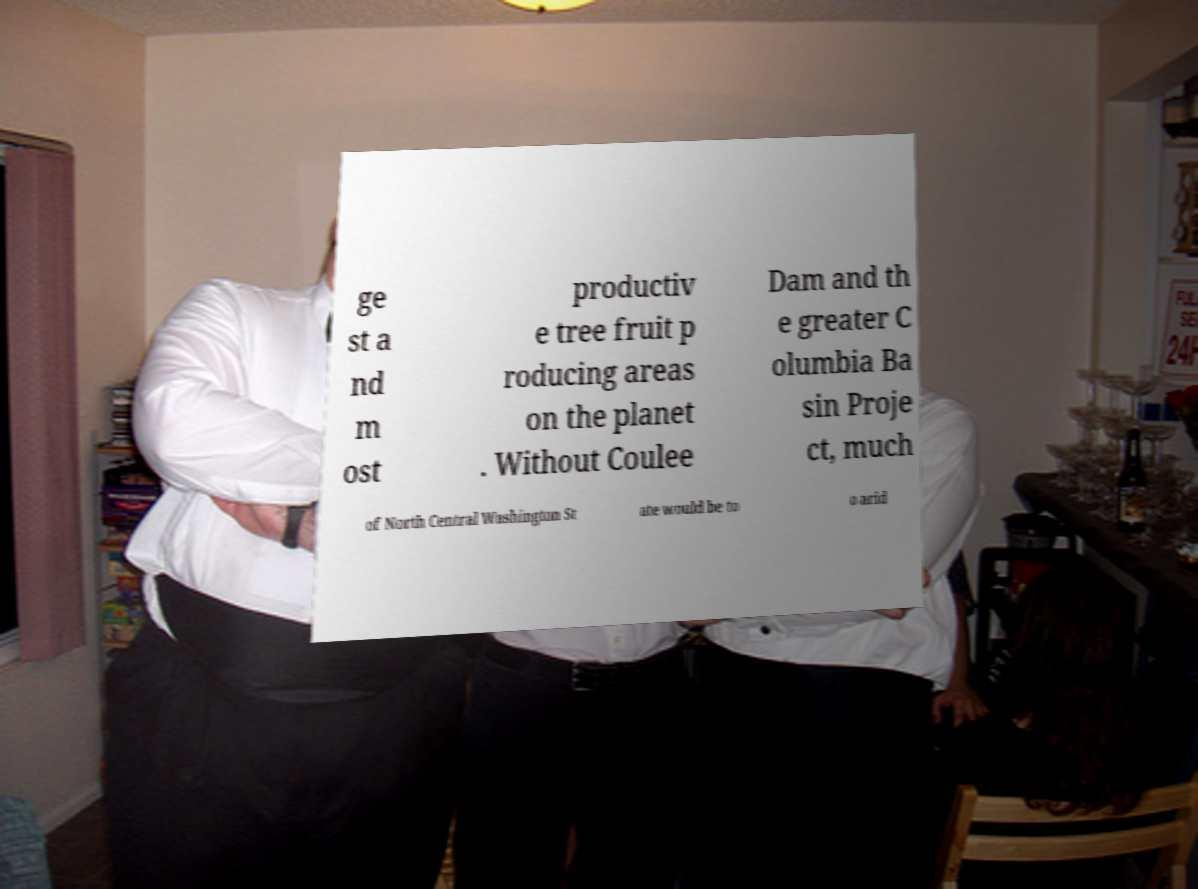Please read and relay the text visible in this image. What does it say? ge st a nd m ost productiv e tree fruit p roducing areas on the planet . Without Coulee Dam and th e greater C olumbia Ba sin Proje ct, much of North Central Washington St ate would be to o arid 